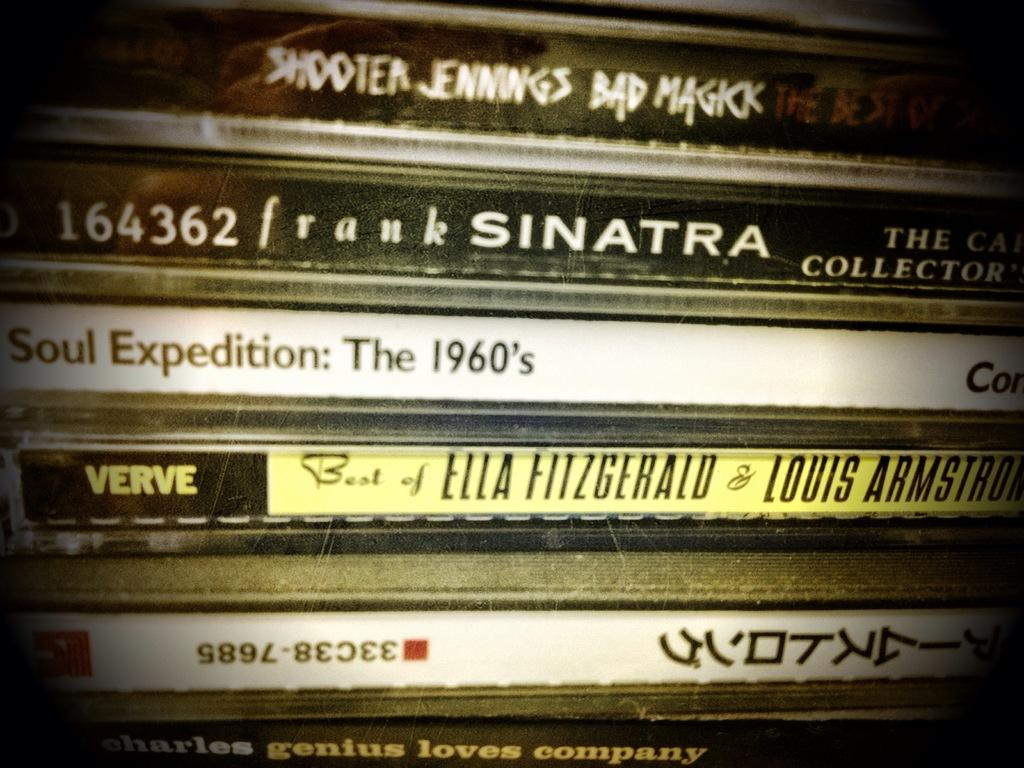<image>
Give a short and clear explanation of the subsequent image. A collection of CDs includes albums by Shooter Jennings, Frank Sinatra, and Ella Fitzgerald. 